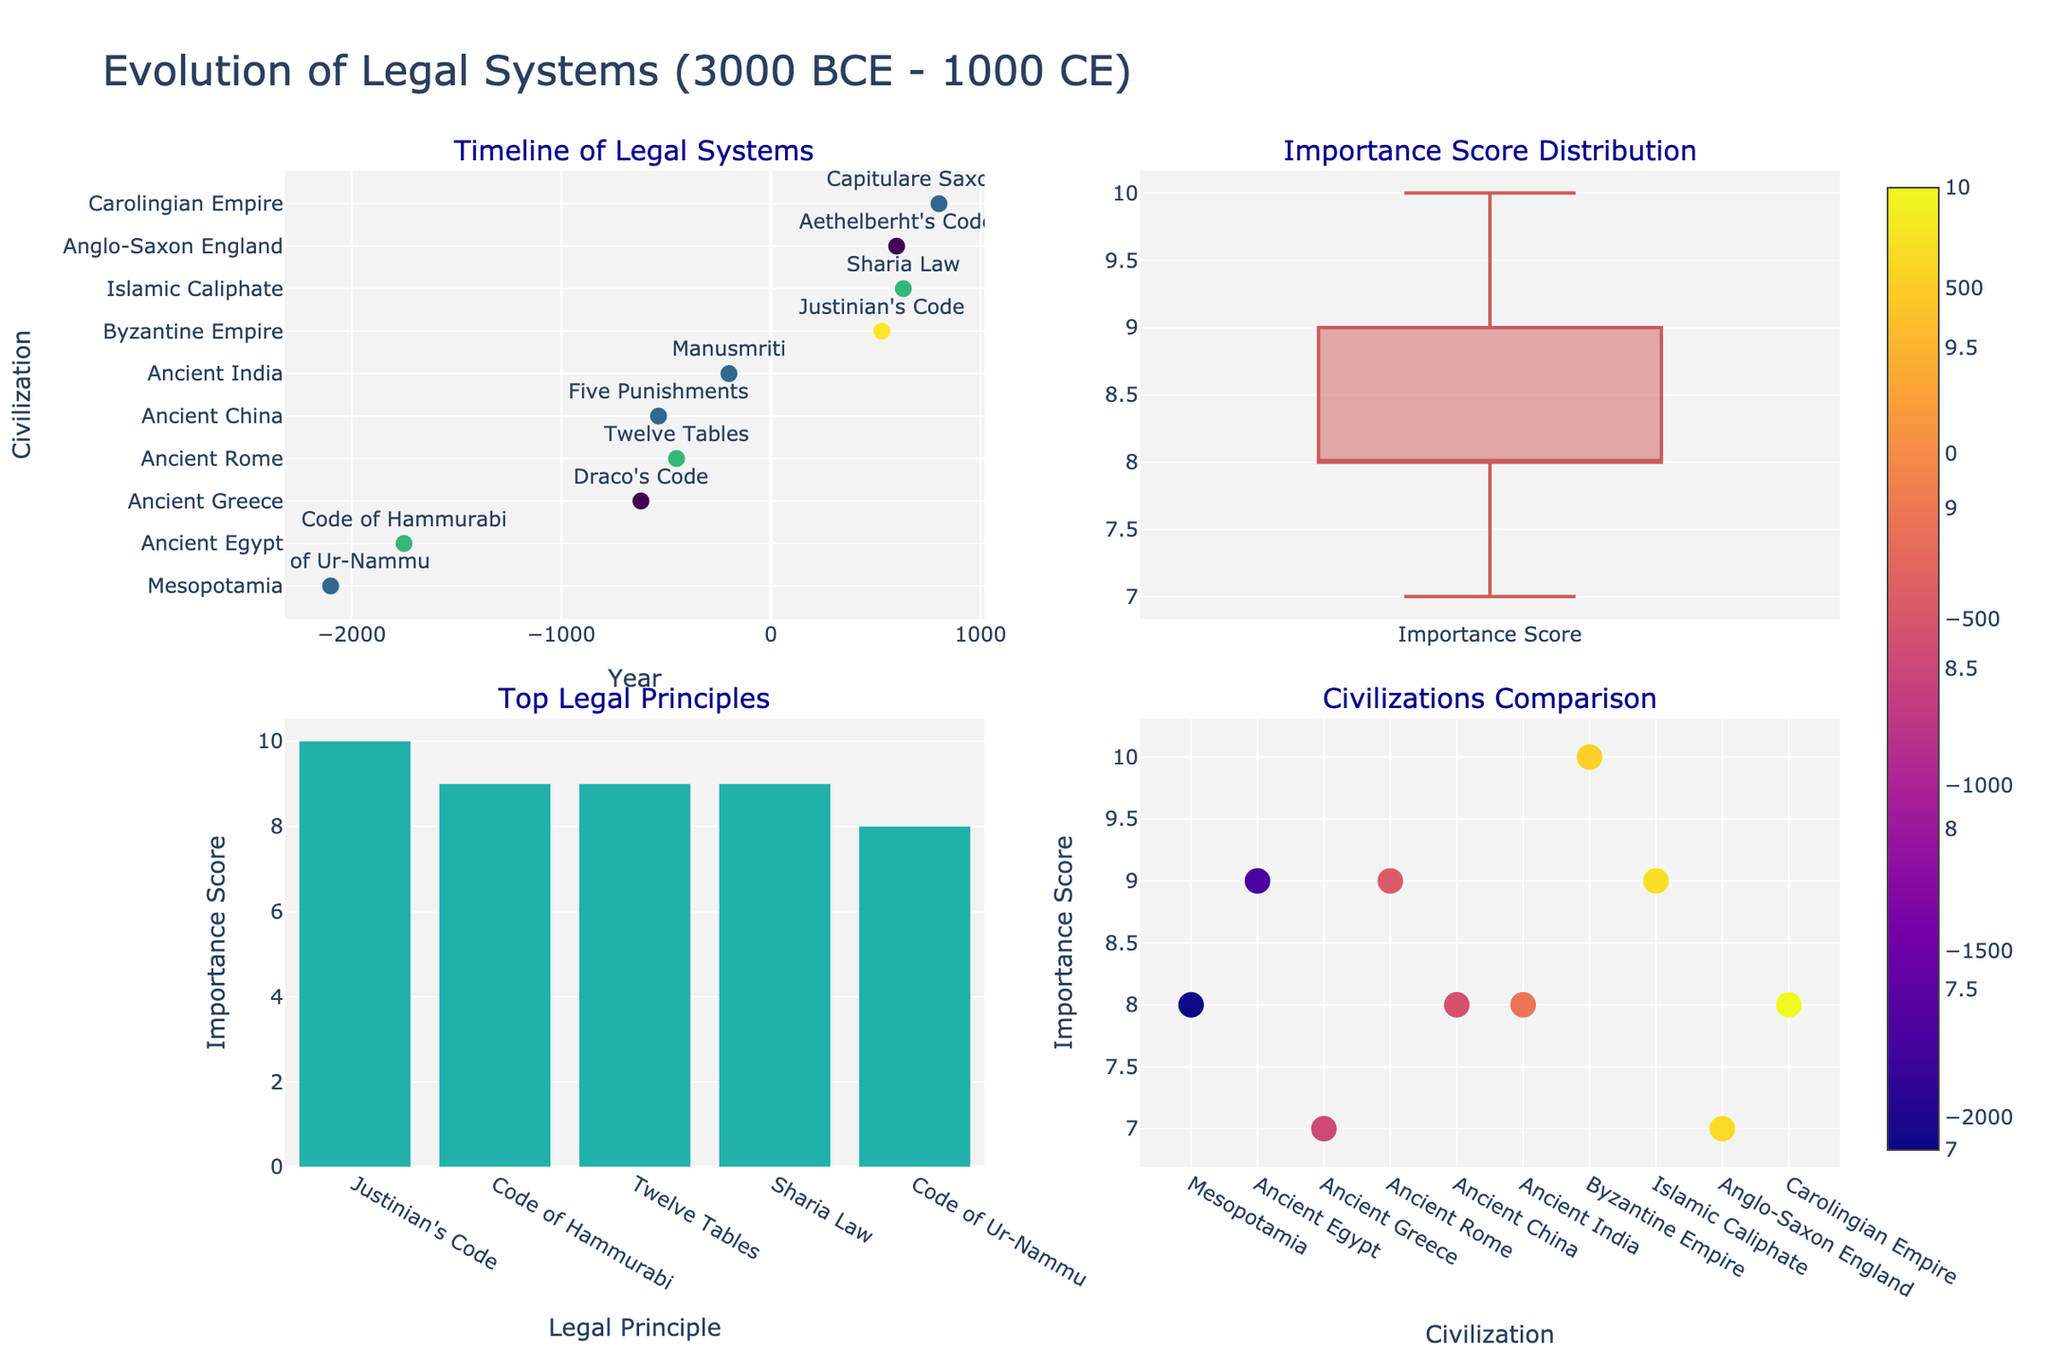what is the title of the figure? The title of the figure is indicated at the top of the plot. It summarizes the main topic of the visualized data.
Answer: Evolution of Legal Systems (3000 BCE - 1000 CE) How many legal systems are represented in the plot? Count the number of different legal principles in the subplots, which often match the number of unique data points or bars for each civilization.
Answer: 10 Which legal principle has the highest Importance Score? Look at the "Top Legal Principles" bar chart on the bottom-left to identify the principle with the tallest bar.
Answer: Justinian's Code Between the Byzantine Empire and the Islamic Caliphate, which one has a higher Importance Score? Compare the Importance Scores of these two civilizations either from the "Timeline" markers or the "Civilizations Comparison" scatter plot on the bottom-right.
Answer: Byzantine Empire What is the range of years shown on the timeline? Identify the earliest and latest points on the "Timeline of Legal Systems" subplot in the top-left to determine the range of years.
Answer: 2100 BCE to 802 CE What is the median Importance Score of the legal principles? Observe the central line of the box in the "Importance Score Distribution" subplot on the top-right. The median is represented here.
Answer: 8 Compare the Importance Scores of Draco's Code and Manusmriti. Which one is higher? Check the "Top Legal Principles" or "Civilizations Comparison" subplots to verify the Importance Scores of both principles and determine which one is higher.
Answer: Draco's Code is higher How many legal principles have Importance Scores of 9 or higher? Count the number of data points or bars that have Importance Scores of 9 or above in any subplot.
Answer: 4 Which year is more recent, the introduction of Justinian’s Code or Aethelberht's Code? Identify the years associated with both principles in the "Timeline of Legal Systems" and compare them.
Answer: Aethelberht's Code is more recent How does the Importance Score of the Twelve Tables compare to that of Sharia Law? Compare the Importance Scores of these two legal principles using either the "Civilizations Comparison" or "Top Legal Principles" subplots. Both scores are visually represented.
Answer: They are equal 